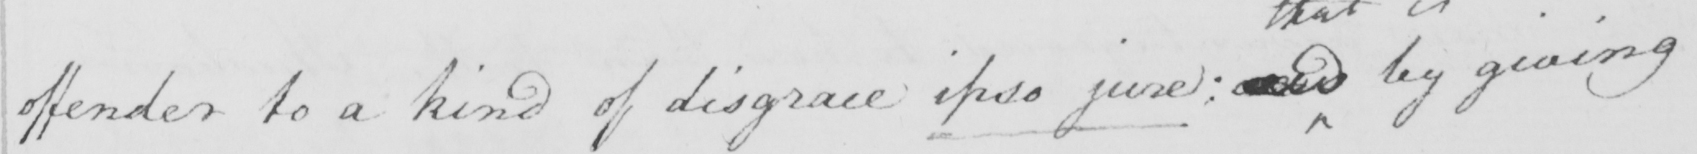Can you tell me what this handwritten text says? offender to a kind of disgrace  ipso jure  ;   <gap/>   by giving 